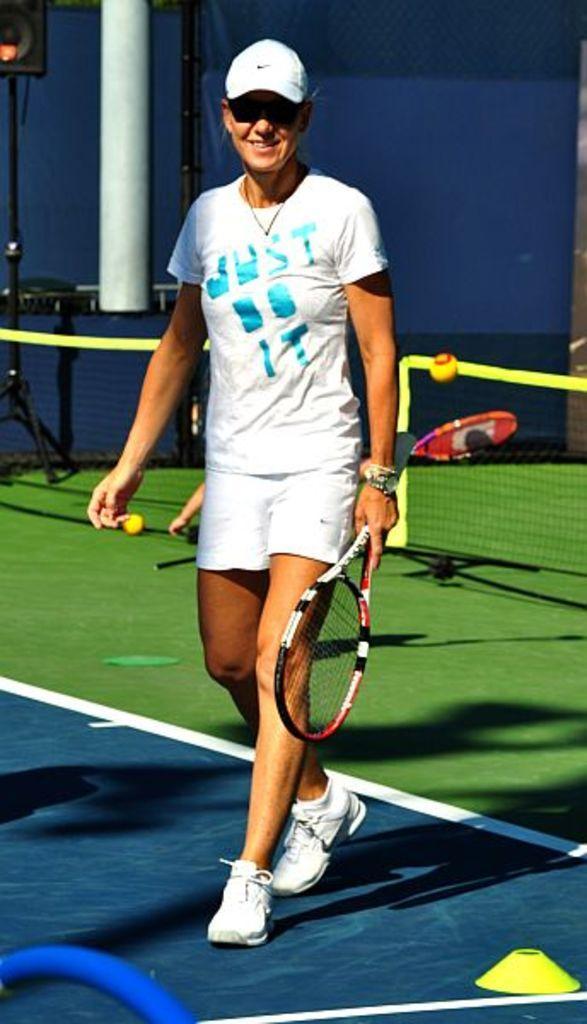Please provide a concise description of this image. In this image I can see a person holding a racket. At the back side there is net and a ball. 